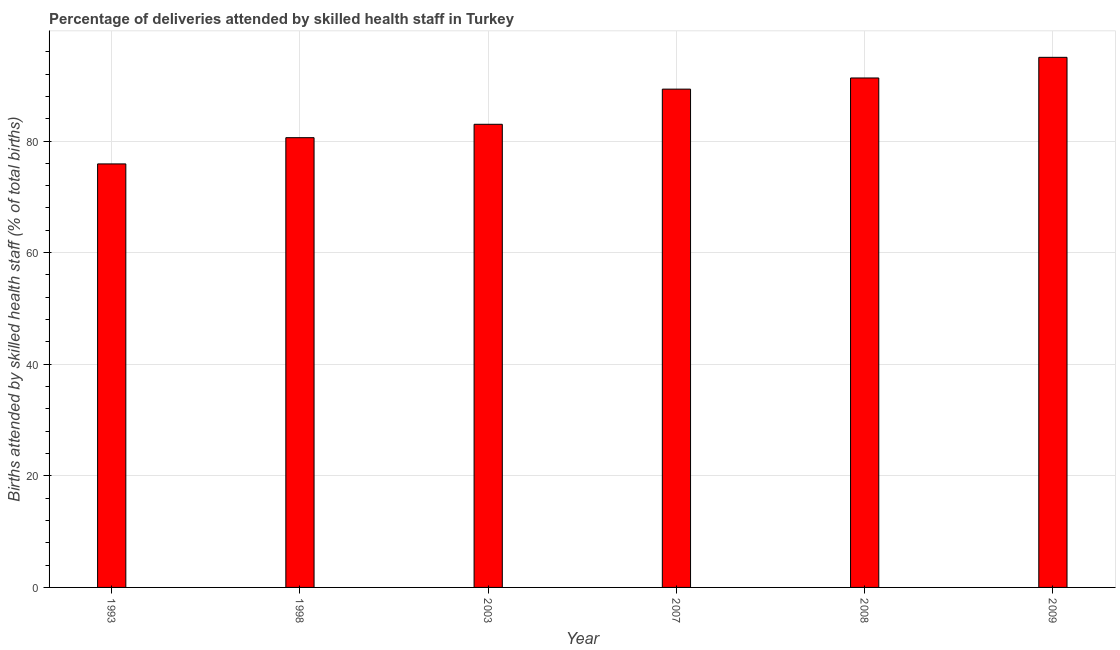Does the graph contain grids?
Offer a very short reply. Yes. What is the title of the graph?
Offer a terse response. Percentage of deliveries attended by skilled health staff in Turkey. What is the label or title of the Y-axis?
Make the answer very short. Births attended by skilled health staff (% of total births). What is the number of births attended by skilled health staff in 2008?
Make the answer very short. 91.3. Across all years, what is the minimum number of births attended by skilled health staff?
Keep it short and to the point. 75.9. In which year was the number of births attended by skilled health staff maximum?
Ensure brevity in your answer.  2009. What is the sum of the number of births attended by skilled health staff?
Keep it short and to the point. 515.1. What is the average number of births attended by skilled health staff per year?
Make the answer very short. 85.85. What is the median number of births attended by skilled health staff?
Provide a succinct answer. 86.15. What is the ratio of the number of births attended by skilled health staff in 2007 to that in 2008?
Provide a succinct answer. 0.98. What is the difference between the highest and the second highest number of births attended by skilled health staff?
Offer a very short reply. 3.7. Is the sum of the number of births attended by skilled health staff in 1993 and 2007 greater than the maximum number of births attended by skilled health staff across all years?
Offer a terse response. Yes. What is the difference between the highest and the lowest number of births attended by skilled health staff?
Your answer should be very brief. 19.1. How many bars are there?
Offer a very short reply. 6. Are all the bars in the graph horizontal?
Keep it short and to the point. No. Are the values on the major ticks of Y-axis written in scientific E-notation?
Keep it short and to the point. No. What is the Births attended by skilled health staff (% of total births) of 1993?
Give a very brief answer. 75.9. What is the Births attended by skilled health staff (% of total births) in 1998?
Your answer should be very brief. 80.6. What is the Births attended by skilled health staff (% of total births) of 2007?
Your answer should be very brief. 89.3. What is the Births attended by skilled health staff (% of total births) in 2008?
Keep it short and to the point. 91.3. What is the Births attended by skilled health staff (% of total births) in 2009?
Your answer should be compact. 95. What is the difference between the Births attended by skilled health staff (% of total births) in 1993 and 2008?
Give a very brief answer. -15.4. What is the difference between the Births attended by skilled health staff (% of total births) in 1993 and 2009?
Your answer should be compact. -19.1. What is the difference between the Births attended by skilled health staff (% of total births) in 1998 and 2007?
Offer a very short reply. -8.7. What is the difference between the Births attended by skilled health staff (% of total births) in 1998 and 2009?
Your response must be concise. -14.4. What is the difference between the Births attended by skilled health staff (% of total births) in 2003 and 2007?
Offer a very short reply. -6.3. What is the difference between the Births attended by skilled health staff (% of total births) in 2007 and 2008?
Make the answer very short. -2. What is the difference between the Births attended by skilled health staff (% of total births) in 2007 and 2009?
Keep it short and to the point. -5.7. What is the difference between the Births attended by skilled health staff (% of total births) in 2008 and 2009?
Ensure brevity in your answer.  -3.7. What is the ratio of the Births attended by skilled health staff (% of total births) in 1993 to that in 1998?
Ensure brevity in your answer.  0.94. What is the ratio of the Births attended by skilled health staff (% of total births) in 1993 to that in 2003?
Provide a short and direct response. 0.91. What is the ratio of the Births attended by skilled health staff (% of total births) in 1993 to that in 2007?
Your answer should be compact. 0.85. What is the ratio of the Births attended by skilled health staff (% of total births) in 1993 to that in 2008?
Your answer should be very brief. 0.83. What is the ratio of the Births attended by skilled health staff (% of total births) in 1993 to that in 2009?
Offer a very short reply. 0.8. What is the ratio of the Births attended by skilled health staff (% of total births) in 1998 to that in 2003?
Offer a terse response. 0.97. What is the ratio of the Births attended by skilled health staff (% of total births) in 1998 to that in 2007?
Keep it short and to the point. 0.9. What is the ratio of the Births attended by skilled health staff (% of total births) in 1998 to that in 2008?
Make the answer very short. 0.88. What is the ratio of the Births attended by skilled health staff (% of total births) in 1998 to that in 2009?
Keep it short and to the point. 0.85. What is the ratio of the Births attended by skilled health staff (% of total births) in 2003 to that in 2007?
Make the answer very short. 0.93. What is the ratio of the Births attended by skilled health staff (% of total births) in 2003 to that in 2008?
Your answer should be very brief. 0.91. What is the ratio of the Births attended by skilled health staff (% of total births) in 2003 to that in 2009?
Your answer should be compact. 0.87. 